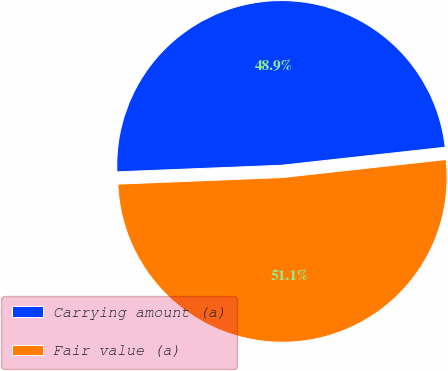Convert chart to OTSL. <chart><loc_0><loc_0><loc_500><loc_500><pie_chart><fcel>Carrying amount (a)<fcel>Fair value (a)<nl><fcel>48.89%<fcel>51.11%<nl></chart> 